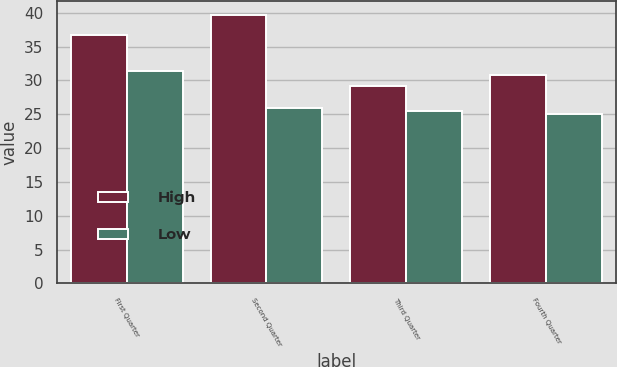Convert chart to OTSL. <chart><loc_0><loc_0><loc_500><loc_500><stacked_bar_chart><ecel><fcel>First Quarter<fcel>Second Quarter<fcel>Third Quarter<fcel>Fourth Quarter<nl><fcel>High<fcel>36.67<fcel>39.71<fcel>29.12<fcel>30.8<nl><fcel>Low<fcel>31.45<fcel>25.91<fcel>25.53<fcel>25.03<nl></chart> 